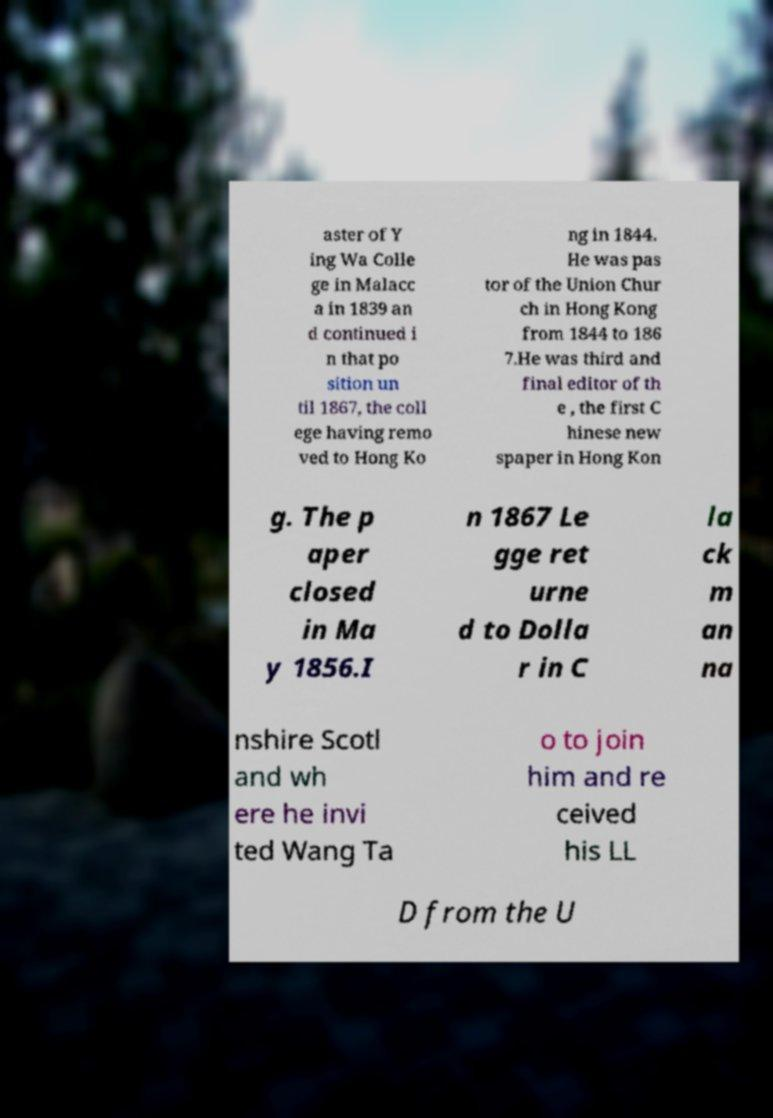Could you extract and type out the text from this image? aster of Y ing Wa Colle ge in Malacc a in 1839 an d continued i n that po sition un til 1867, the coll ege having remo ved to Hong Ko ng in 1844. He was pas tor of the Union Chur ch in Hong Kong from 1844 to 186 7.He was third and final editor of th e , the first C hinese new spaper in Hong Kon g. The p aper closed in Ma y 1856.I n 1867 Le gge ret urne d to Dolla r in C la ck m an na nshire Scotl and wh ere he invi ted Wang Ta o to join him and re ceived his LL D from the U 